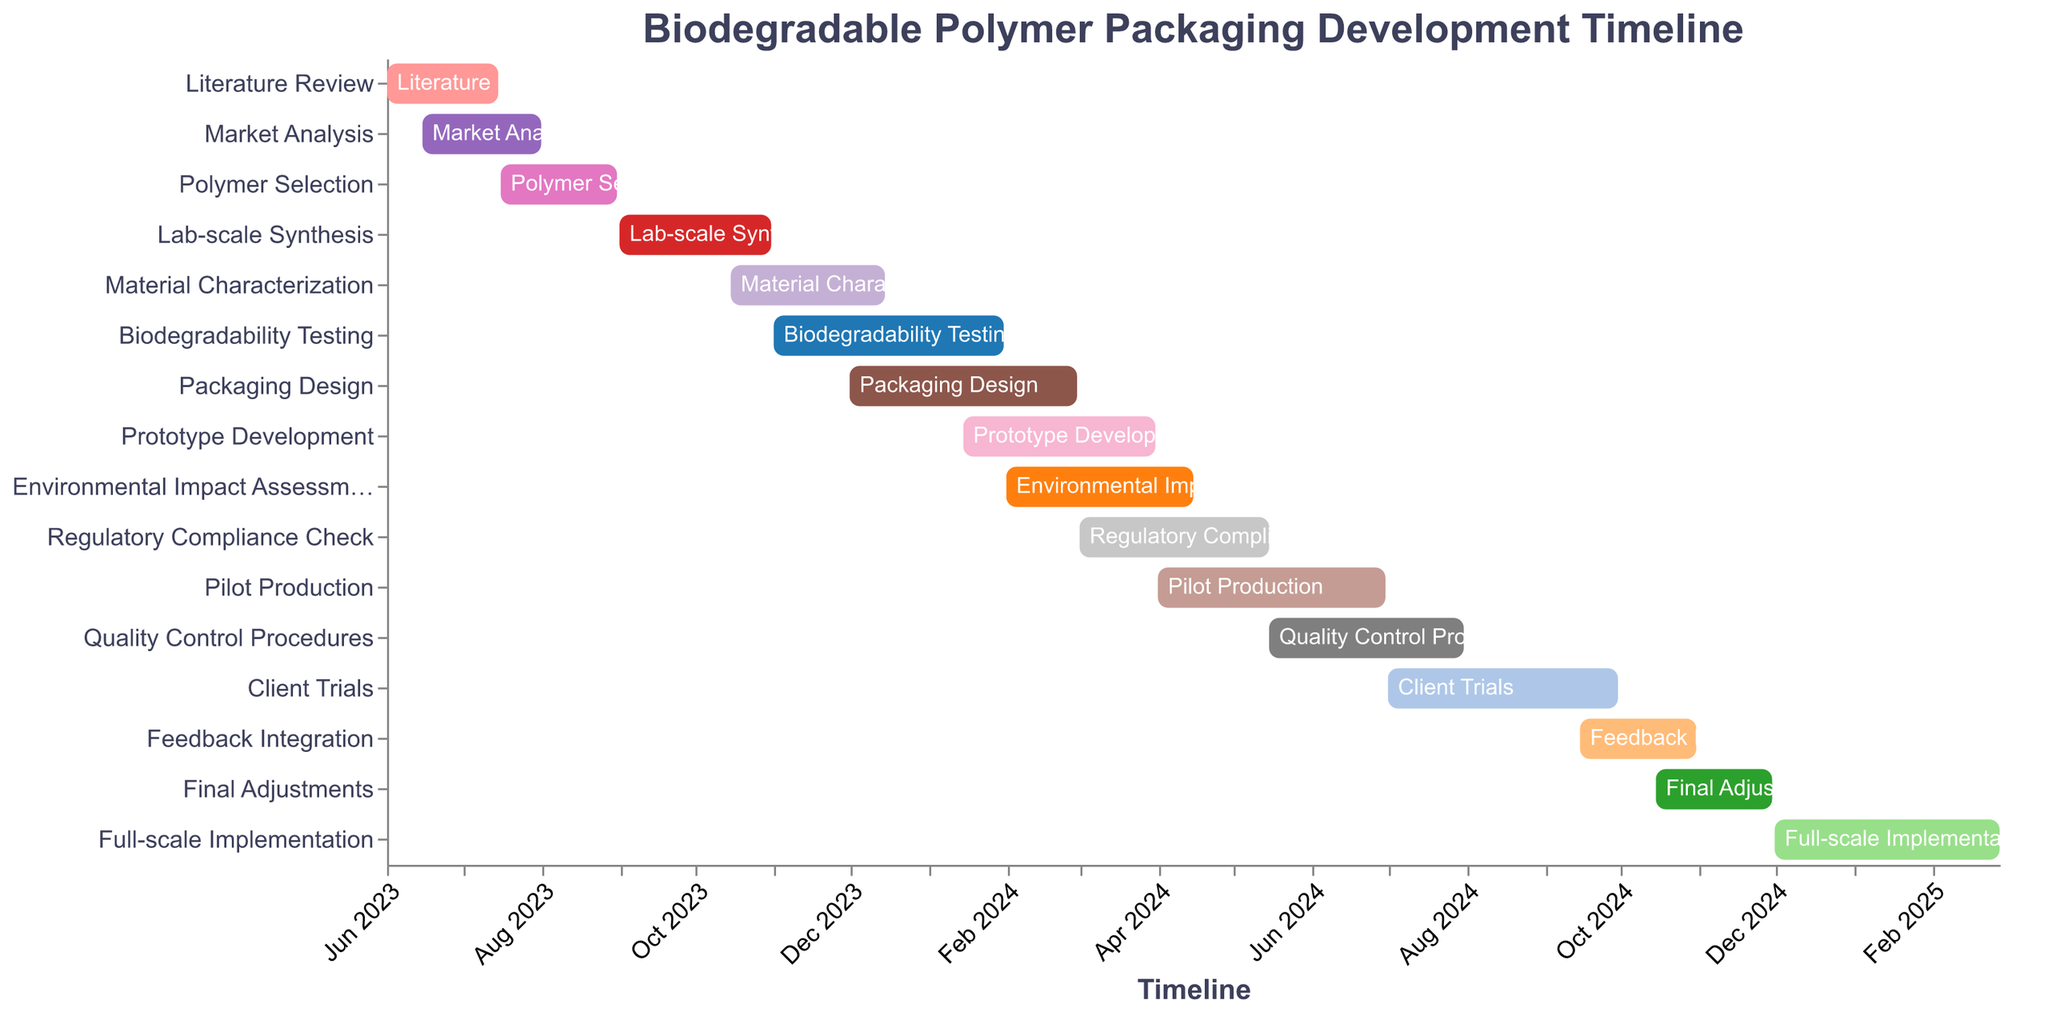What is the title of the Gantt Chart? The title is typically displayed at the top of the Gantt Chart, making it easily noticeable.
Answer: Biodegradable Polymer Packaging Development Timeline Which task takes the longest time to complete? To determine the longest task, check the duration of each task by comparing their start and end dates and find the one with the longest span.
Answer: Client Trials How many tasks are scheduled to end in December 2023? Identify all tasks that have their end dates within December 2023 from the Gantt Chart timeline.
Answer: 1 Which tasks are overlapping with "Market Analysis"? Look for tasks whose dates overlap with the start date (2023-06-15) and end date (2023-08-01) of Market Analysis.
Answer: Literature Review, Polymer Selection What is the duration of the "Prototype Development" phase? Calculate the span of the Prototype Development phase by subtracting its start date (2024-01-15) from its end date (2024-03-31).
Answer: 2.5 months In which month does the "Environmental Impact Assessment" start? Inspect the chart for the start date of the Environmental Impact Assessment task and convert it to the corresponding month.
Answer: February 2024 Compare the durations of "Lab-scale Synthesis" and "Biodegradability Testing". Which is longer? Find the durations of both tasks by comparing the spans between their start and end dates and identify the longer one.
Answer: Biodegradability Testing How many tasks are set to begin in January 2024? Look at the timeline to identify the number of tasks with a start date in January 2024.
Answer: 1 When does the "Full-scale Implementation" phase begin and end? Check the timeline for the start and end dates of the Full-scale Implementation task.
Answer: Starts: Dec 2024, Ends: Feb 2025 Is there any task that starts immediately after "Lab-scale Synthesis"? Find the end date of Lab-scale Synthesis (2023-10-31) and see if any task begins on this date or immediately after.
Answer: No 